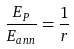Convert formula to latex. <formula><loc_0><loc_0><loc_500><loc_500>\frac { E _ { P } } { E _ { a n n } } = \frac { 1 } { r }</formula> 